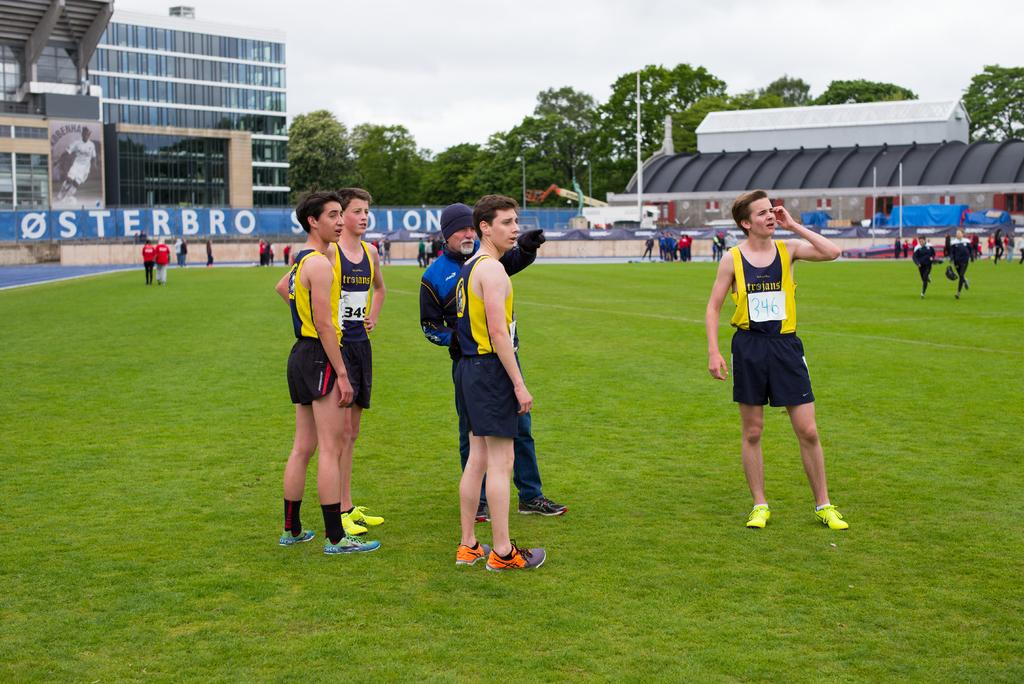What are the people in the image standing on? The people in the image are standing on the ground. What type of vegetation is present on the ground? There is grass on the ground in the image. What can be seen in the background of the image? There are buildings, trees, and the sky visible in the background of the image. What type of toothbrush is being used by the people in the image? There is no toothbrush present in the image; the people are standing on the ground with grass around them. 